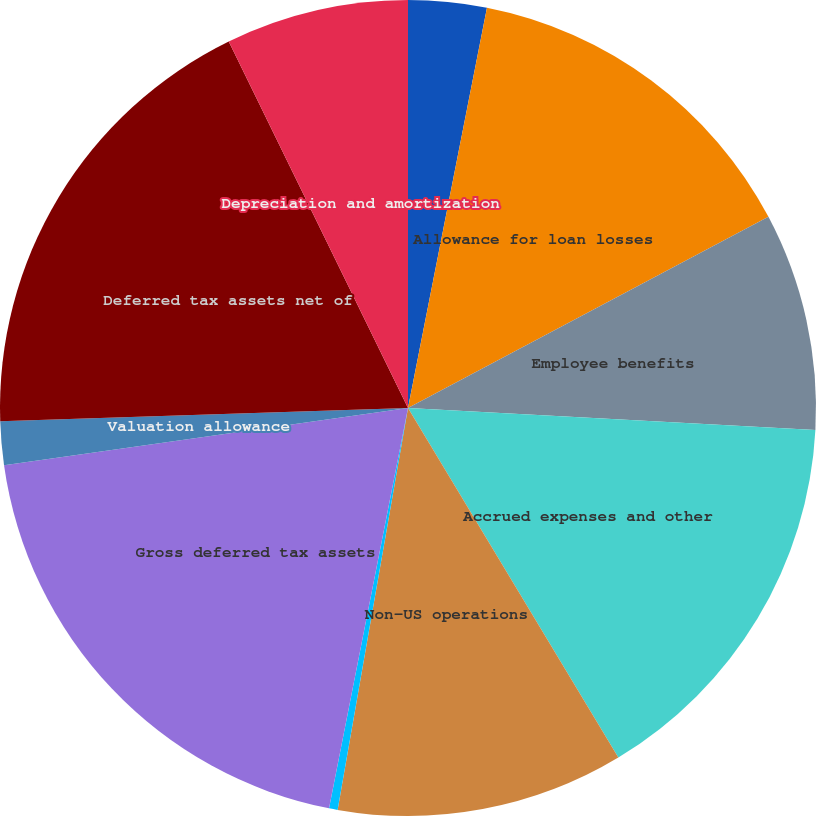Convert chart. <chart><loc_0><loc_0><loc_500><loc_500><pie_chart><fcel>December 31 (in millions)<fcel>Allowance for loan losses<fcel>Employee benefits<fcel>Accrued expenses and other<fcel>Non-US operations<fcel>Tax attribute carryforwards<fcel>Gross deferred tax assets<fcel>Valuation allowance<fcel>Deferred tax assets net of<fcel>Depreciation and amortization<nl><fcel>3.1%<fcel>14.14%<fcel>8.62%<fcel>15.52%<fcel>11.38%<fcel>0.34%<fcel>19.66%<fcel>1.72%<fcel>18.28%<fcel>7.24%<nl></chart> 